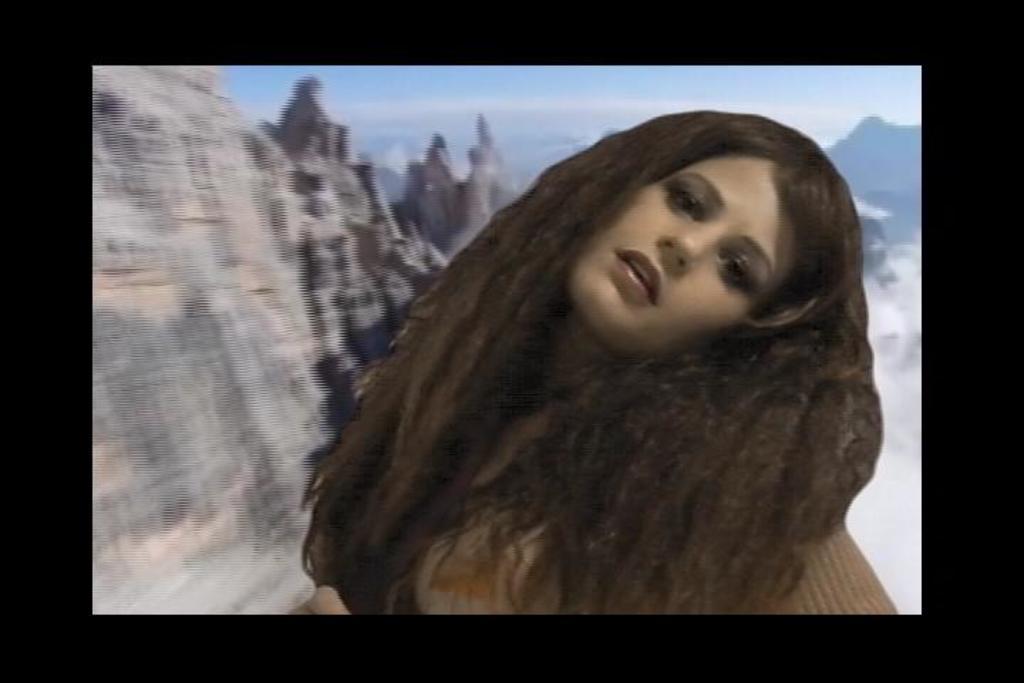Could you give a brief overview of what you see in this image? In this image there is an edited picture. Front side of the image there is a woman. Behind her there are hills. Top of the image there is sky. 